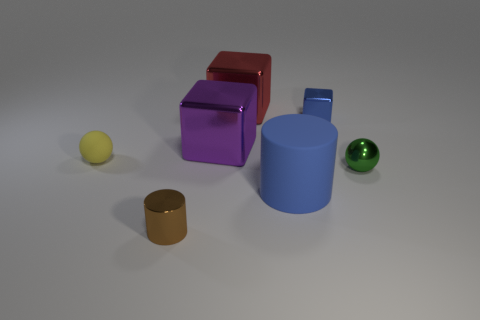Subtract all large purple cubes. How many cubes are left? 2 Subtract 1 blocks. How many blocks are left? 2 Add 1 large gray blocks. How many objects exist? 8 Subtract all spheres. How many objects are left? 5 Subtract all brown blocks. Subtract all cyan balls. How many blocks are left? 3 Subtract all big cyan shiny cylinders. Subtract all green shiny things. How many objects are left? 6 Add 1 small things. How many small things are left? 5 Add 1 small cyan metal balls. How many small cyan metal balls exist? 1 Subtract 1 red cubes. How many objects are left? 6 